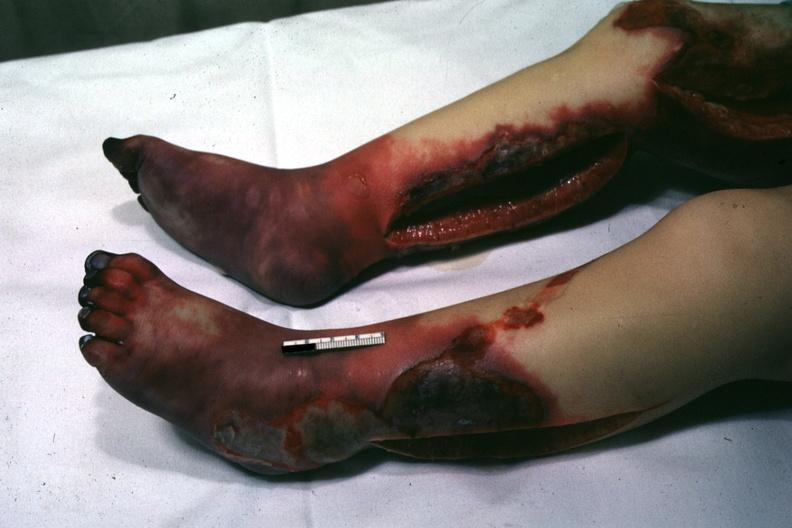re extremities present?
Answer the question using a single word or phrase. Yes 